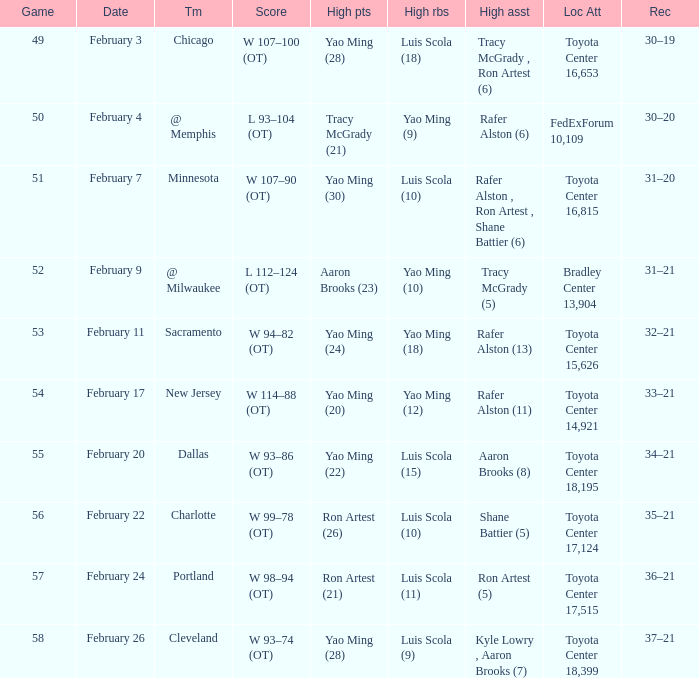Name the record for score of  l 93–104 (ot) 30–20. 